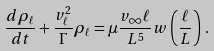Convert formula to latex. <formula><loc_0><loc_0><loc_500><loc_500>\frac { d \rho _ { \ell } } { d t } + \frac { v _ { \ell } ^ { 2 } } { \Gamma } \rho _ { \ell } = \mu \frac { v _ { \infty } \ell } { L ^ { 5 } } w \left ( \frac { \ell } { L } \right ) \, .</formula> 